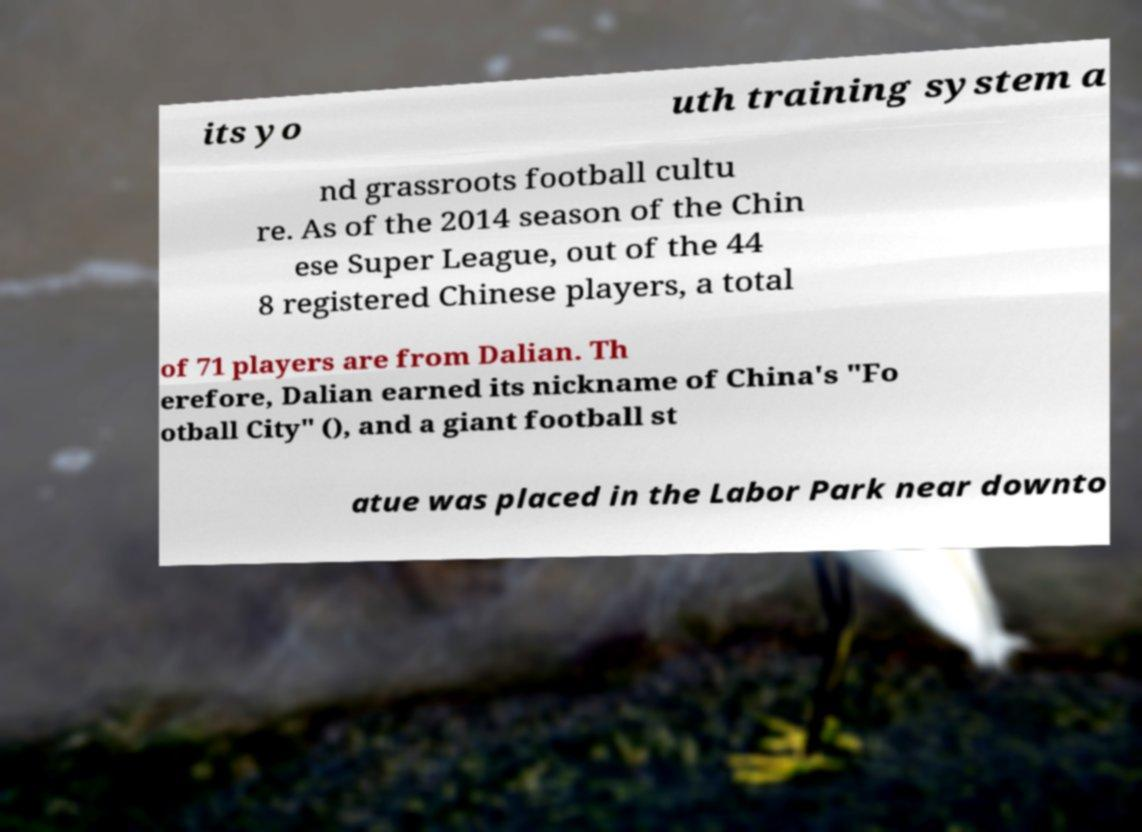Could you extract and type out the text from this image? its yo uth training system a nd grassroots football cultu re. As of the 2014 season of the Chin ese Super League, out of the 44 8 registered Chinese players, a total of 71 players are from Dalian. Th erefore, Dalian earned its nickname of China's "Fo otball City" (), and a giant football st atue was placed in the Labor Park near downto 